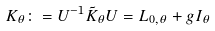Convert formula to latex. <formula><loc_0><loc_0><loc_500><loc_500>K _ { \theta } \colon = U ^ { - 1 } \tilde { K } _ { \theta } U = L _ { 0 , \theta } + g I _ { \theta }</formula> 